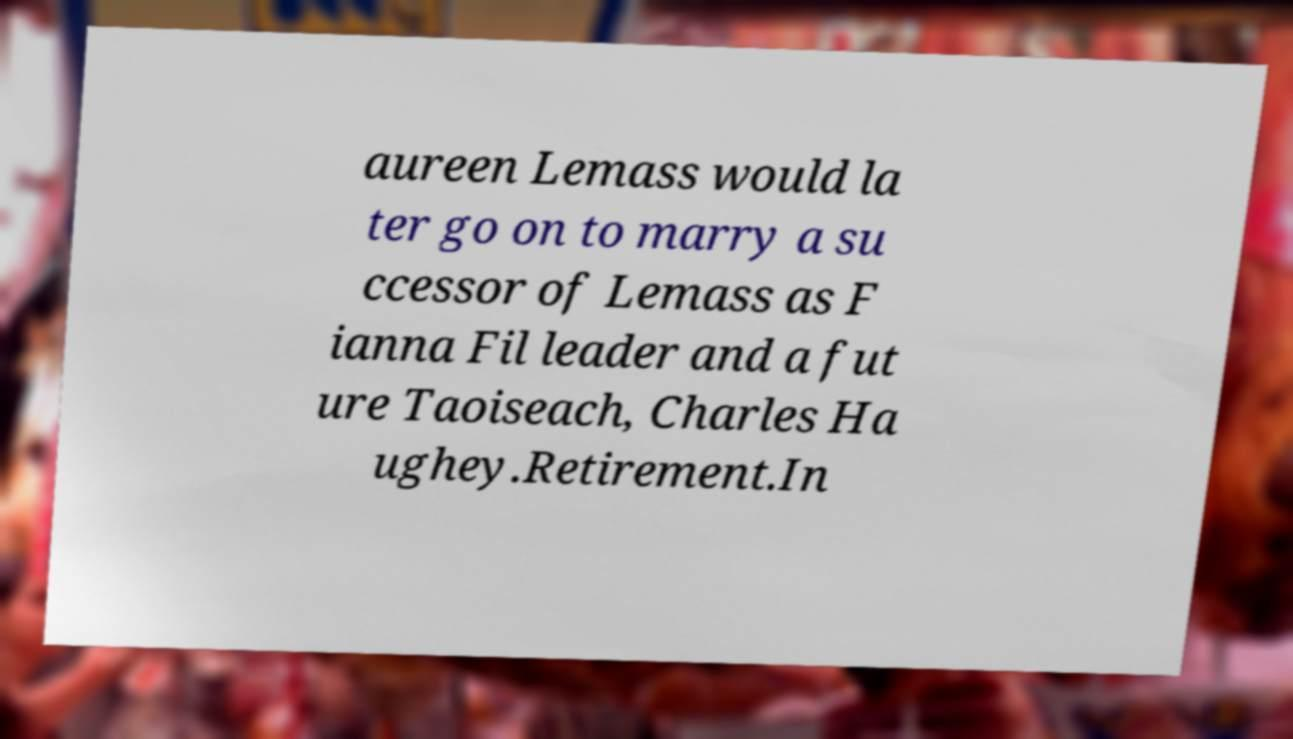I need the written content from this picture converted into text. Can you do that? aureen Lemass would la ter go on to marry a su ccessor of Lemass as F ianna Fil leader and a fut ure Taoiseach, Charles Ha ughey.Retirement.In 